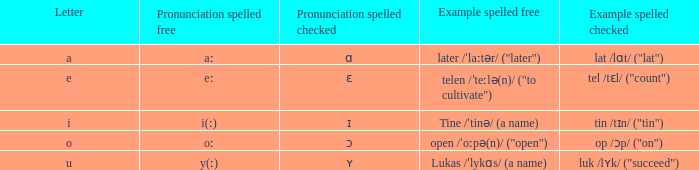What is Example Spelled Free, when Example Spelled Checked is "op /ɔp/ ("on")"? Open /ˈoːpə(n)/ ("open"). 